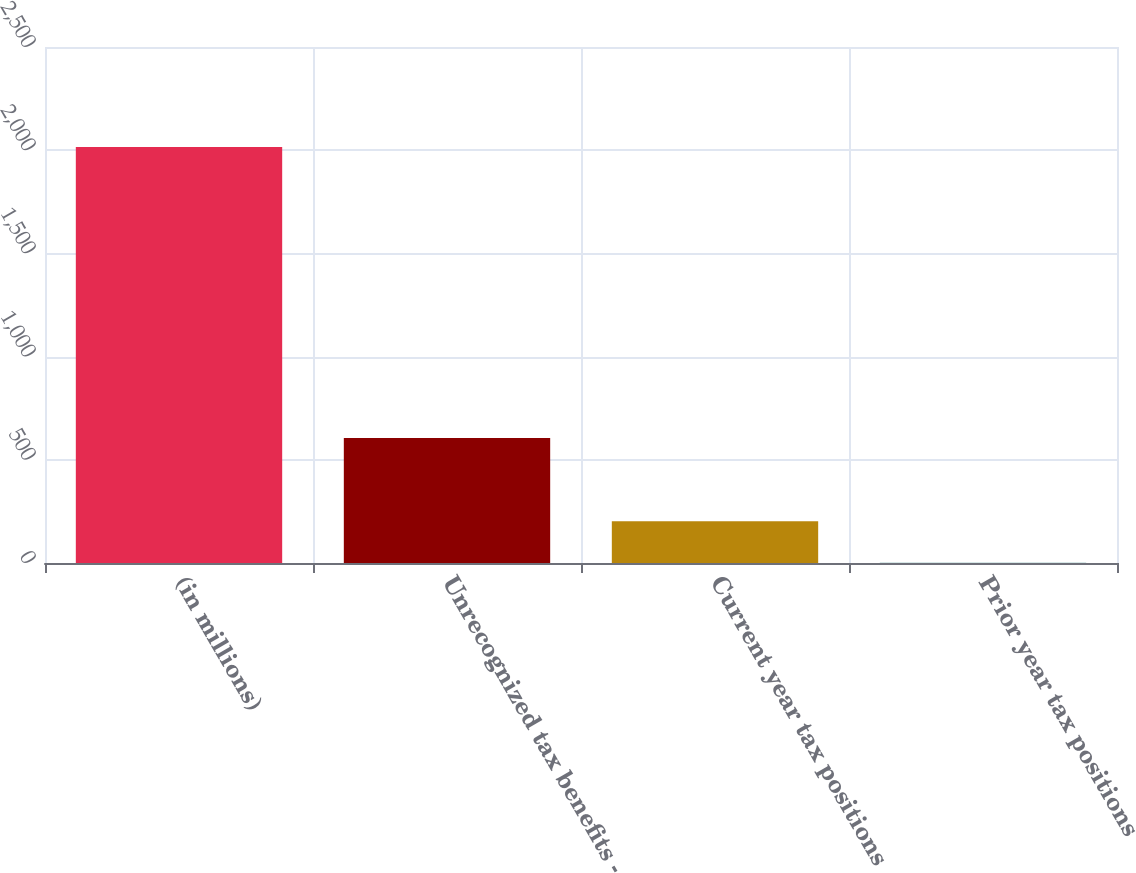Convert chart to OTSL. <chart><loc_0><loc_0><loc_500><loc_500><bar_chart><fcel>(in millions)<fcel>Unrecognized tax benefits -<fcel>Current year tax positions<fcel>Prior year tax positions<nl><fcel>2015<fcel>605.2<fcel>202.4<fcel>1<nl></chart> 